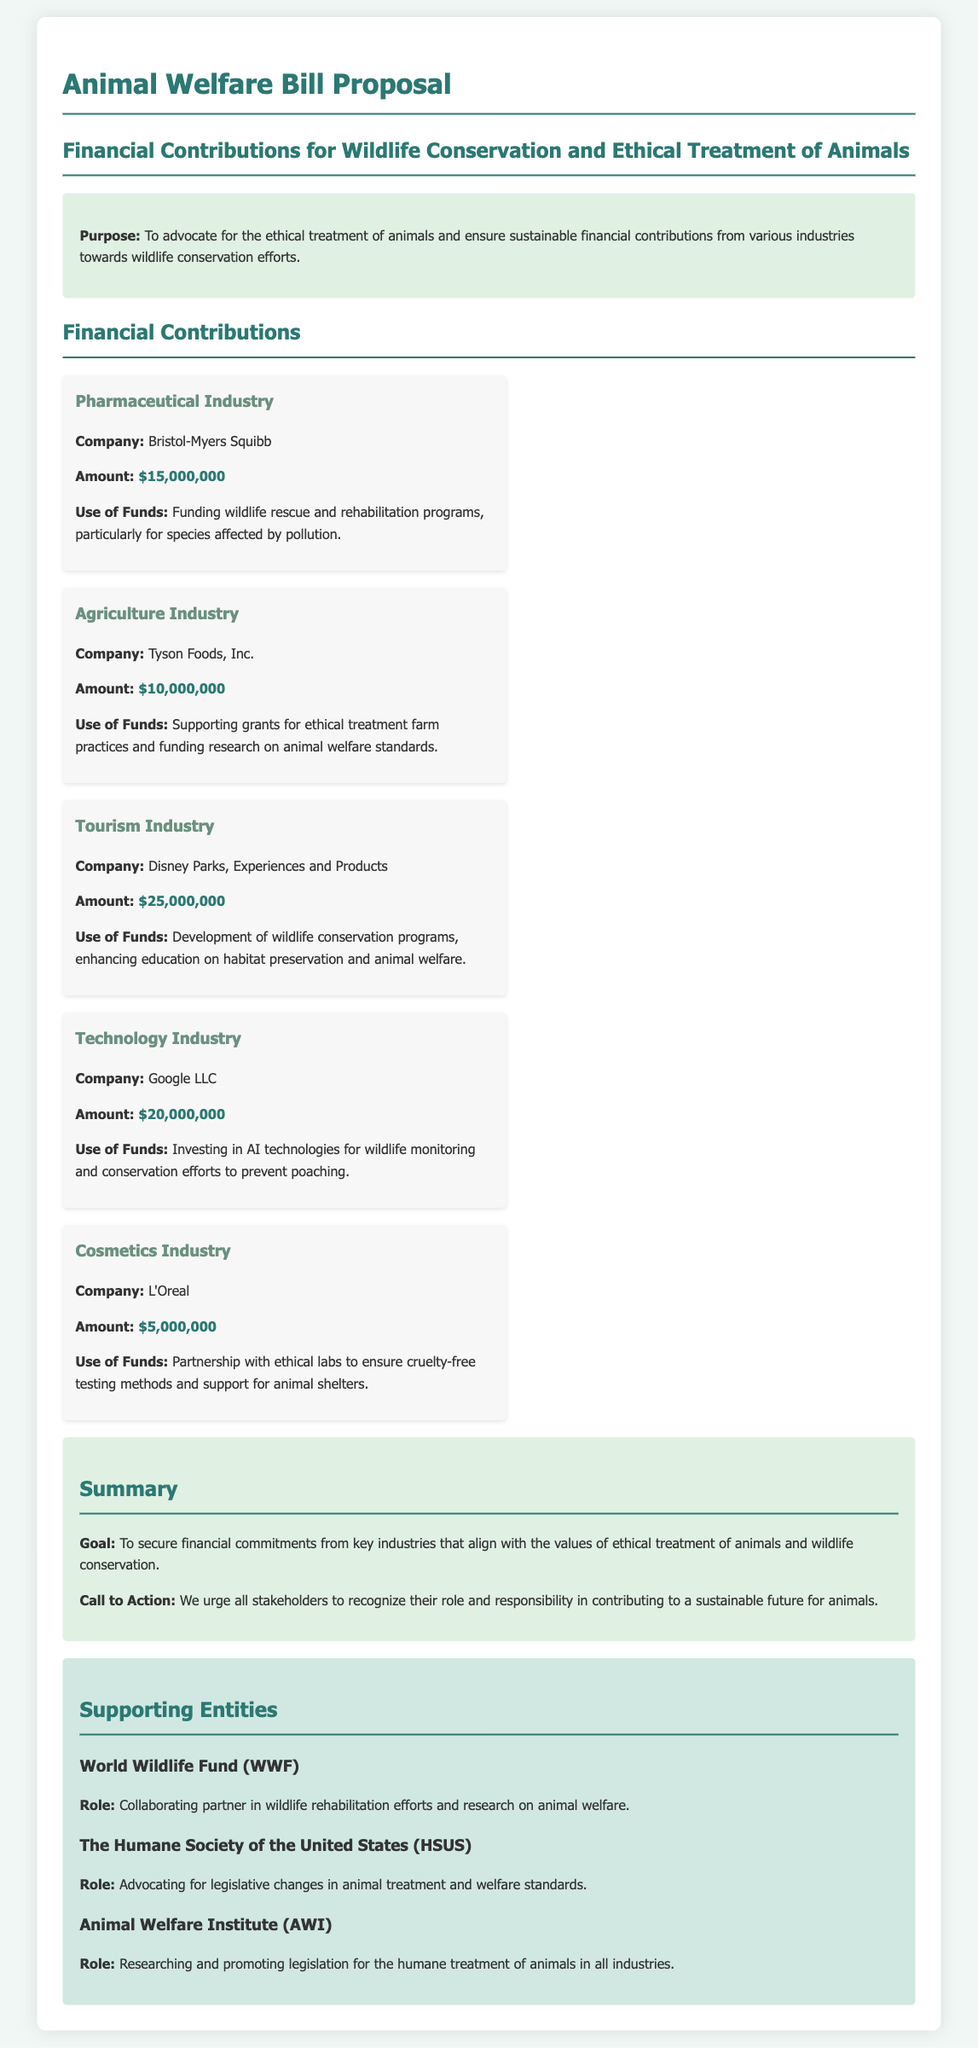what is the total financial contribution of the Pharmaceutical Industry? The document states that Bristol-Myers Squibb from the Pharmaceutical Industry contributed $15,000,000.
Answer: $15,000,000 what is the primary use of funds for Disney Parks, Experiences and Products? The document mentions that the funds are used for the development of wildlife conservation programs and enhancing education on habitat preservation and animal welfare.
Answer: Development of wildlife conservation programs which industry contributed the least amount of money? According to the document, the Cosmetics Industry, represented by L'Oreal, contributed $5,000,000, which is the lowest amount listed.
Answer: $5,000,000 who is the collaborating partner in wildlife rehabilitation efforts? The document indicates that the World Wildlife Fund (WWF) is the collaborating partner.
Answer: World Wildlife Fund (WWF) how much did Google LLC contribute towards animal welfare? The document specifies that Google LLC from the Technology Industry contributed $20,000,000.
Answer: $20,000,000 what is the goal of the Animal Welfare Bill Proposal? The goal stated in the document is to secure financial commitments from key industries that align with ethical treatment of animals and wildlife conservation.
Answer: To secure financial commitments which organization advocates for legislative changes in animal treatment? The document states that The Humane Society of the United States (HSUS) advocates for this cause.
Answer: The Humane Society of the United States (HSUS) what industry does Tyson Foods, Inc. belong to? The document categorizes Tyson Foods, Inc. under the Agriculture Industry.
Answer: Agriculture Industry what is the total contribution from the Tourism Industry? According to the document, Disney Parks, Experiences and Products contributed $25,000,000 to the Tourism Industry.
Answer: $25,000,000 